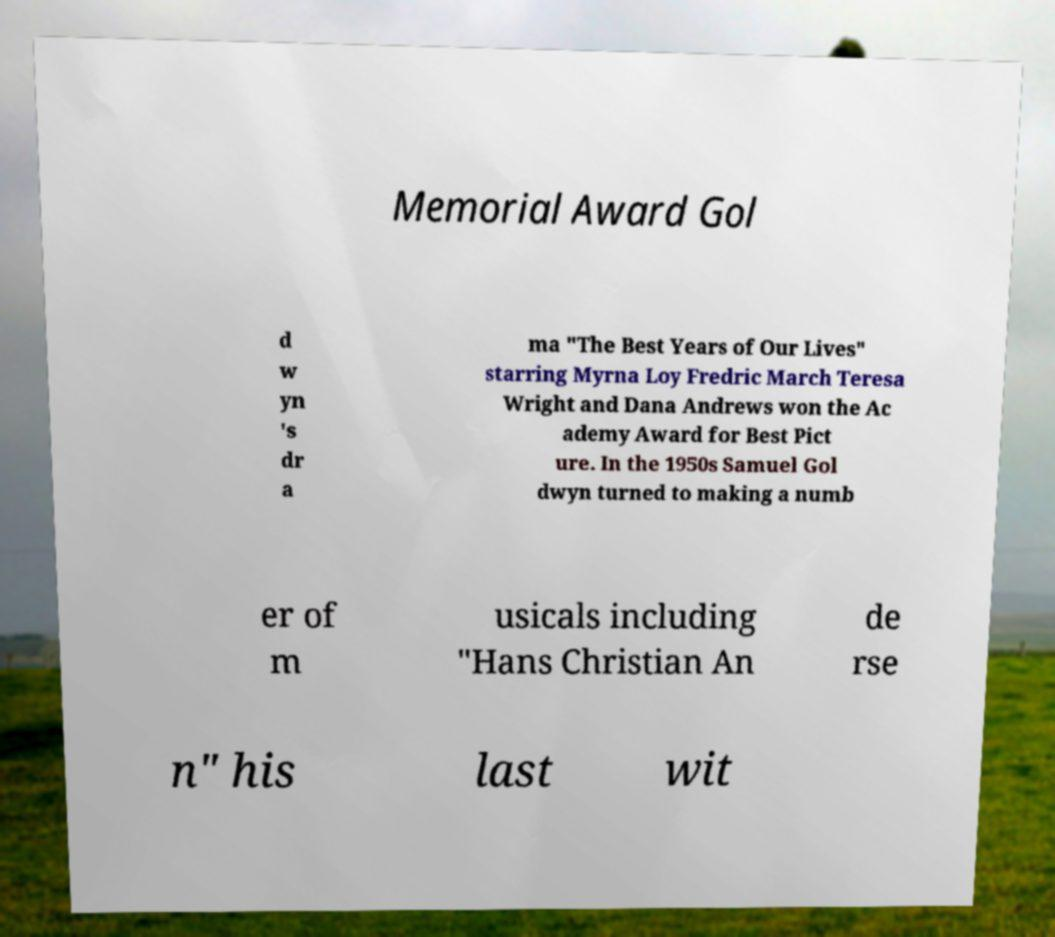Could you assist in decoding the text presented in this image and type it out clearly? Memorial Award Gol d w yn 's dr a ma "The Best Years of Our Lives" starring Myrna Loy Fredric March Teresa Wright and Dana Andrews won the Ac ademy Award for Best Pict ure. In the 1950s Samuel Gol dwyn turned to making a numb er of m usicals including "Hans Christian An de rse n" his last wit 